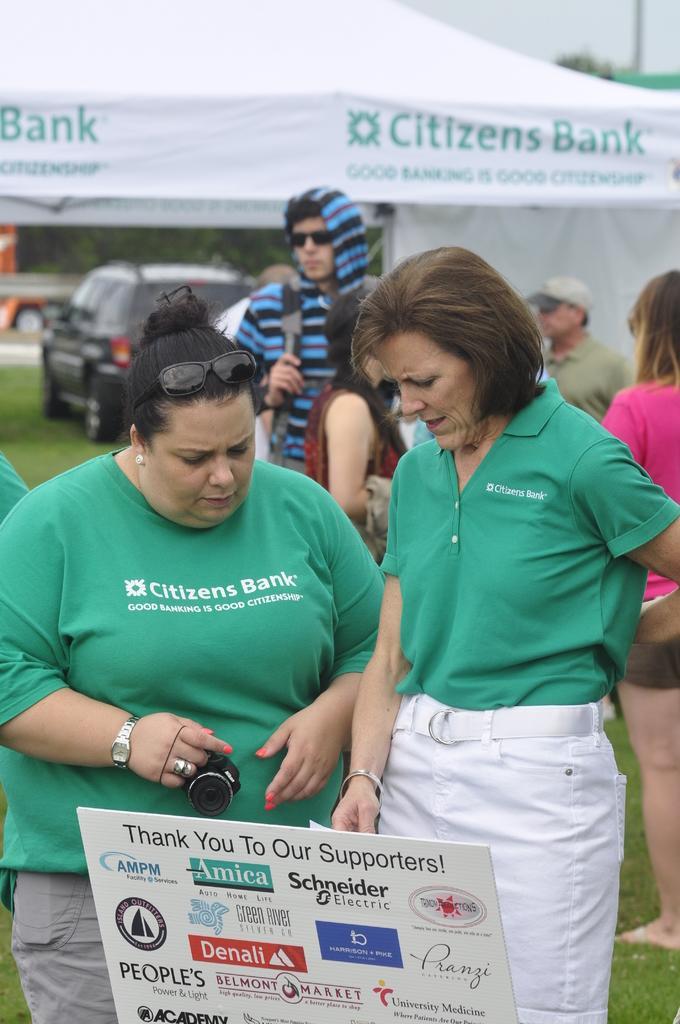Can you describe this image briefly? In this picture we can see few persons. There is a woman holding a camera. Here we can see a hoarding, grass, car, and a tent. In the background we can see sky. 